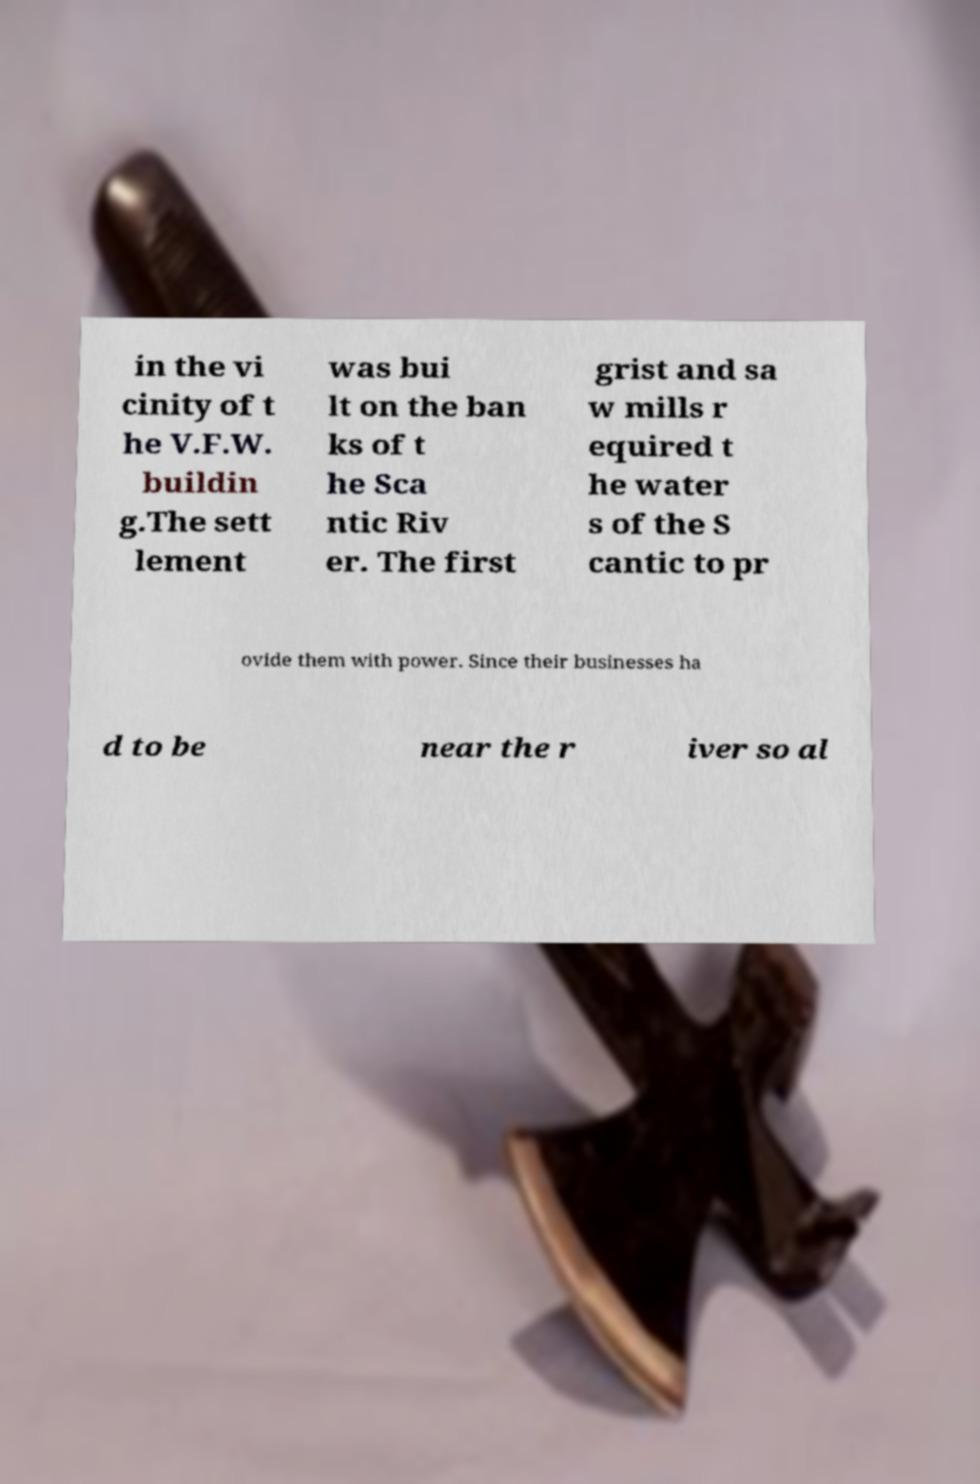There's text embedded in this image that I need extracted. Can you transcribe it verbatim? in the vi cinity of t he V.F.W. buildin g.The sett lement was bui lt on the ban ks of t he Sca ntic Riv er. The first grist and sa w mills r equired t he water s of the S cantic to pr ovide them with power. Since their businesses ha d to be near the r iver so al 